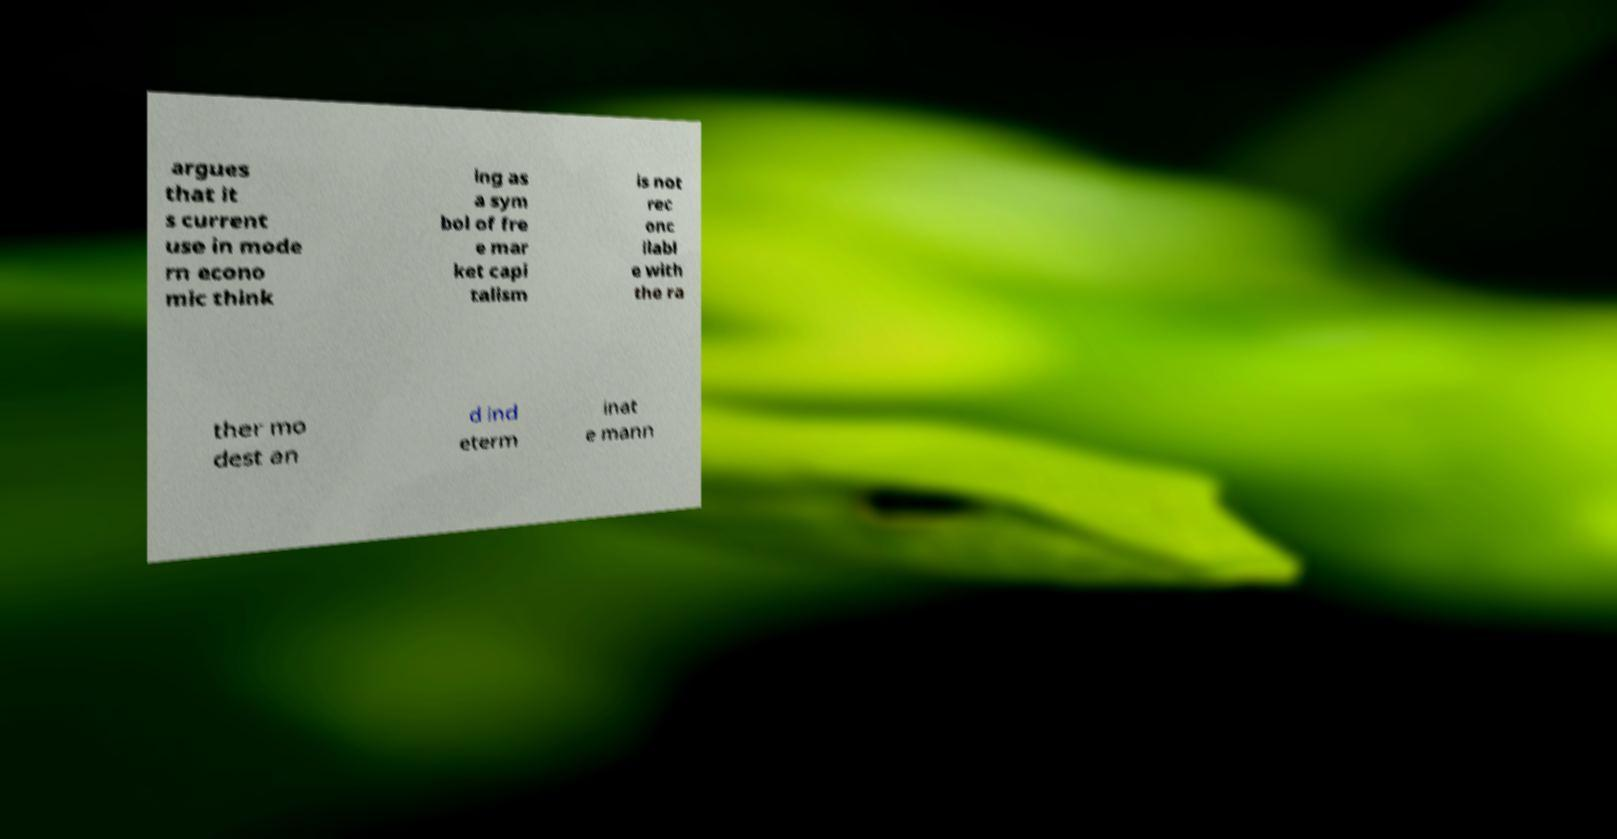Please read and relay the text visible in this image. What does it say? argues that it s current use in mode rn econo mic think ing as a sym bol of fre e mar ket capi talism is not rec onc ilabl e with the ra ther mo dest an d ind eterm inat e mann 